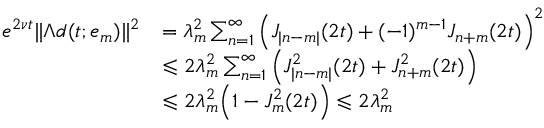Convert formula to latex. <formula><loc_0><loc_0><loc_500><loc_500>\begin{array} { r l } { e ^ { 2 \nu t } \| \Lambda d ( t ; e _ { m } ) \| ^ { 2 } } & { = \lambda _ { m } ^ { 2 } \sum _ { n = 1 } ^ { \infty } \left ( J _ { | n - m | } ( 2 t ) + ( - 1 ) ^ { m - 1 } J _ { n + m } ( 2 t ) \right ) ^ { 2 } } \\ & { \leqslant 2 \lambda _ { m } ^ { 2 } \sum _ { n = 1 } ^ { \infty } \left ( J _ { | n - m | } ^ { 2 } ( 2 t ) + J _ { n + m } ^ { 2 } ( 2 t ) \right ) } \\ & { \leqslant 2 \lambda _ { m } ^ { 2 } \left ( 1 - J _ { m } ^ { 2 } ( 2 t ) \right ) \leqslant 2 \lambda _ { m } ^ { 2 } } \end{array}</formula> 